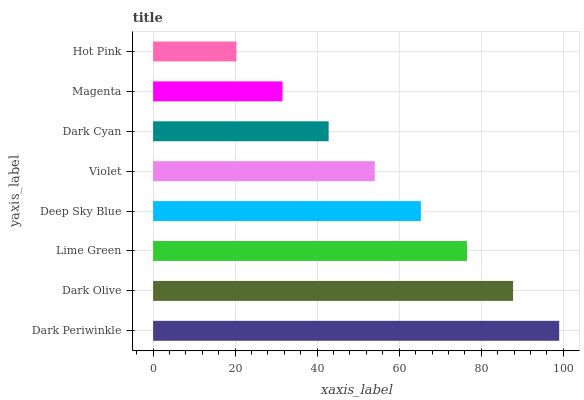Is Hot Pink the minimum?
Answer yes or no. Yes. Is Dark Periwinkle the maximum?
Answer yes or no. Yes. Is Dark Olive the minimum?
Answer yes or no. No. Is Dark Olive the maximum?
Answer yes or no. No. Is Dark Periwinkle greater than Dark Olive?
Answer yes or no. Yes. Is Dark Olive less than Dark Periwinkle?
Answer yes or no. Yes. Is Dark Olive greater than Dark Periwinkle?
Answer yes or no. No. Is Dark Periwinkle less than Dark Olive?
Answer yes or no. No. Is Deep Sky Blue the high median?
Answer yes or no. Yes. Is Violet the low median?
Answer yes or no. Yes. Is Magenta the high median?
Answer yes or no. No. Is Magenta the low median?
Answer yes or no. No. 